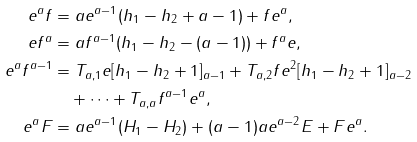Convert formula to latex. <formula><loc_0><loc_0><loc_500><loc_500>e ^ { a } f & = a e ^ { a - 1 } ( h _ { 1 } - h _ { 2 } + a - 1 ) + f e ^ { a } , \\ e f ^ { a } & = a f ^ { a - 1 } ( h _ { 1 } - h _ { 2 } - ( a - 1 ) ) + f ^ { a } e , \\ e ^ { a } f ^ { a - 1 } & = T _ { a , 1 } e [ h _ { 1 } - h _ { 2 } + 1 ] _ { a - 1 } + T _ { a , 2 } f e ^ { 2 } [ h _ { 1 } - h _ { 2 } + 1 ] _ { a - 2 } \\ & \quad + \dots + T _ { a , a } f ^ { a - 1 } e ^ { a } , \\ e ^ { a } F & = a e ^ { a - 1 } ( H _ { 1 } - H _ { 2 } ) + ( a - 1 ) a e ^ { a - 2 } E + F e ^ { a } .</formula> 